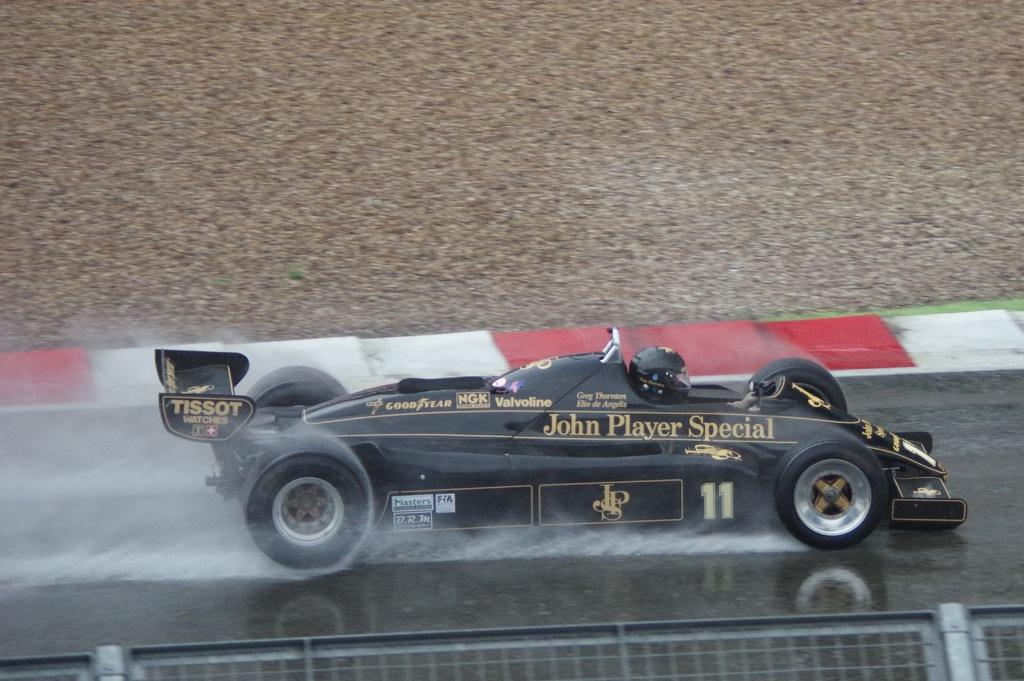What is the person in the image doing? The person is in a sports car in the image. What can be seen in the background of the image? There is water visible in the image. What is the barrier in the image made of? There is a fence in the image. What type of plate is being used to fight in the image? There is no plate or fighting present in the image. What kind of tail is attached to the sports car in the image? There is no tail attached to the sports car in the image. 